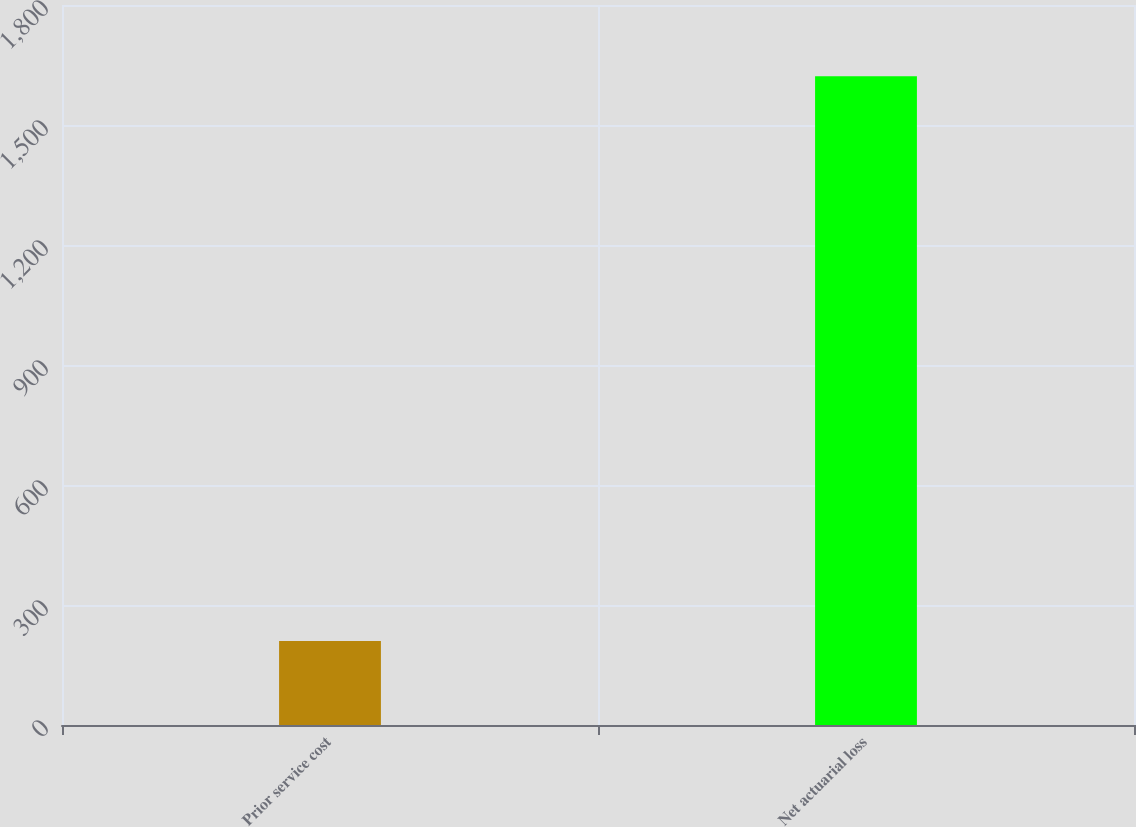Convert chart to OTSL. <chart><loc_0><loc_0><loc_500><loc_500><bar_chart><fcel>Prior service cost<fcel>Net actuarial loss<nl><fcel>210<fcel>1622<nl></chart> 